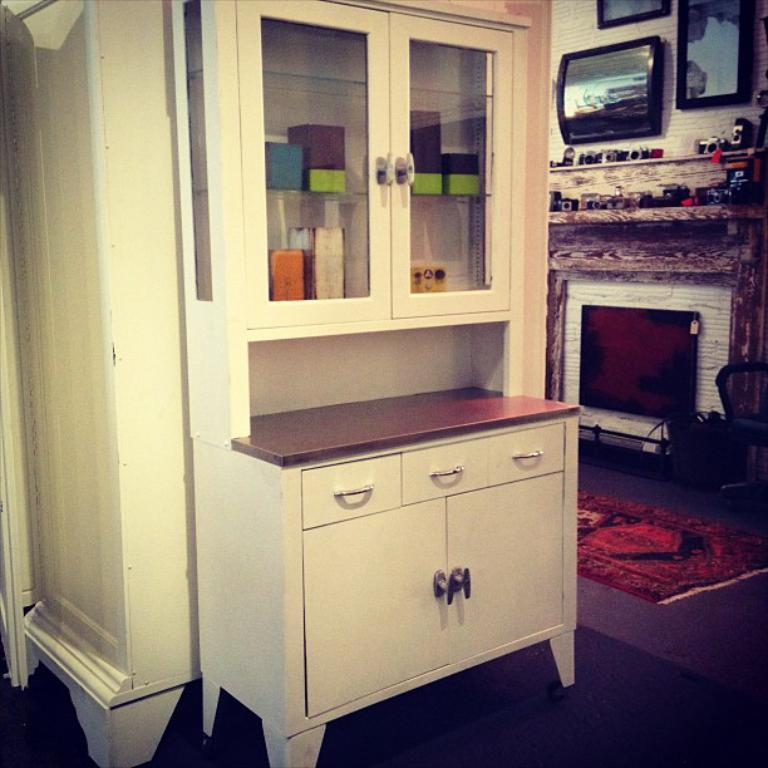What is located in the left corner of the image? There is a white color almirah in the left corner of the image. What can be seen in the right corner of the image? There are other objects in the right corner of the image. What type of flesh can be seen hanging from the almirah in the image? There is no flesh present in the image; it features an almirah and other objects. Is there a curtain covering the almirah in the image? There is no mention of a curtain in the image; it only describes an almirah and other objects. 